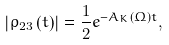<formula> <loc_0><loc_0><loc_500><loc_500>\left | \rho _ { 2 3 } \left ( t \right ) \right | = \frac { 1 } { 2 } e ^ { - A _ { K } \left ( \Omega \right ) t } ,</formula> 